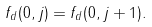Convert formula to latex. <formula><loc_0><loc_0><loc_500><loc_500>f _ { d } ( 0 , j ) = f _ { d } ( 0 , j + 1 ) .</formula> 